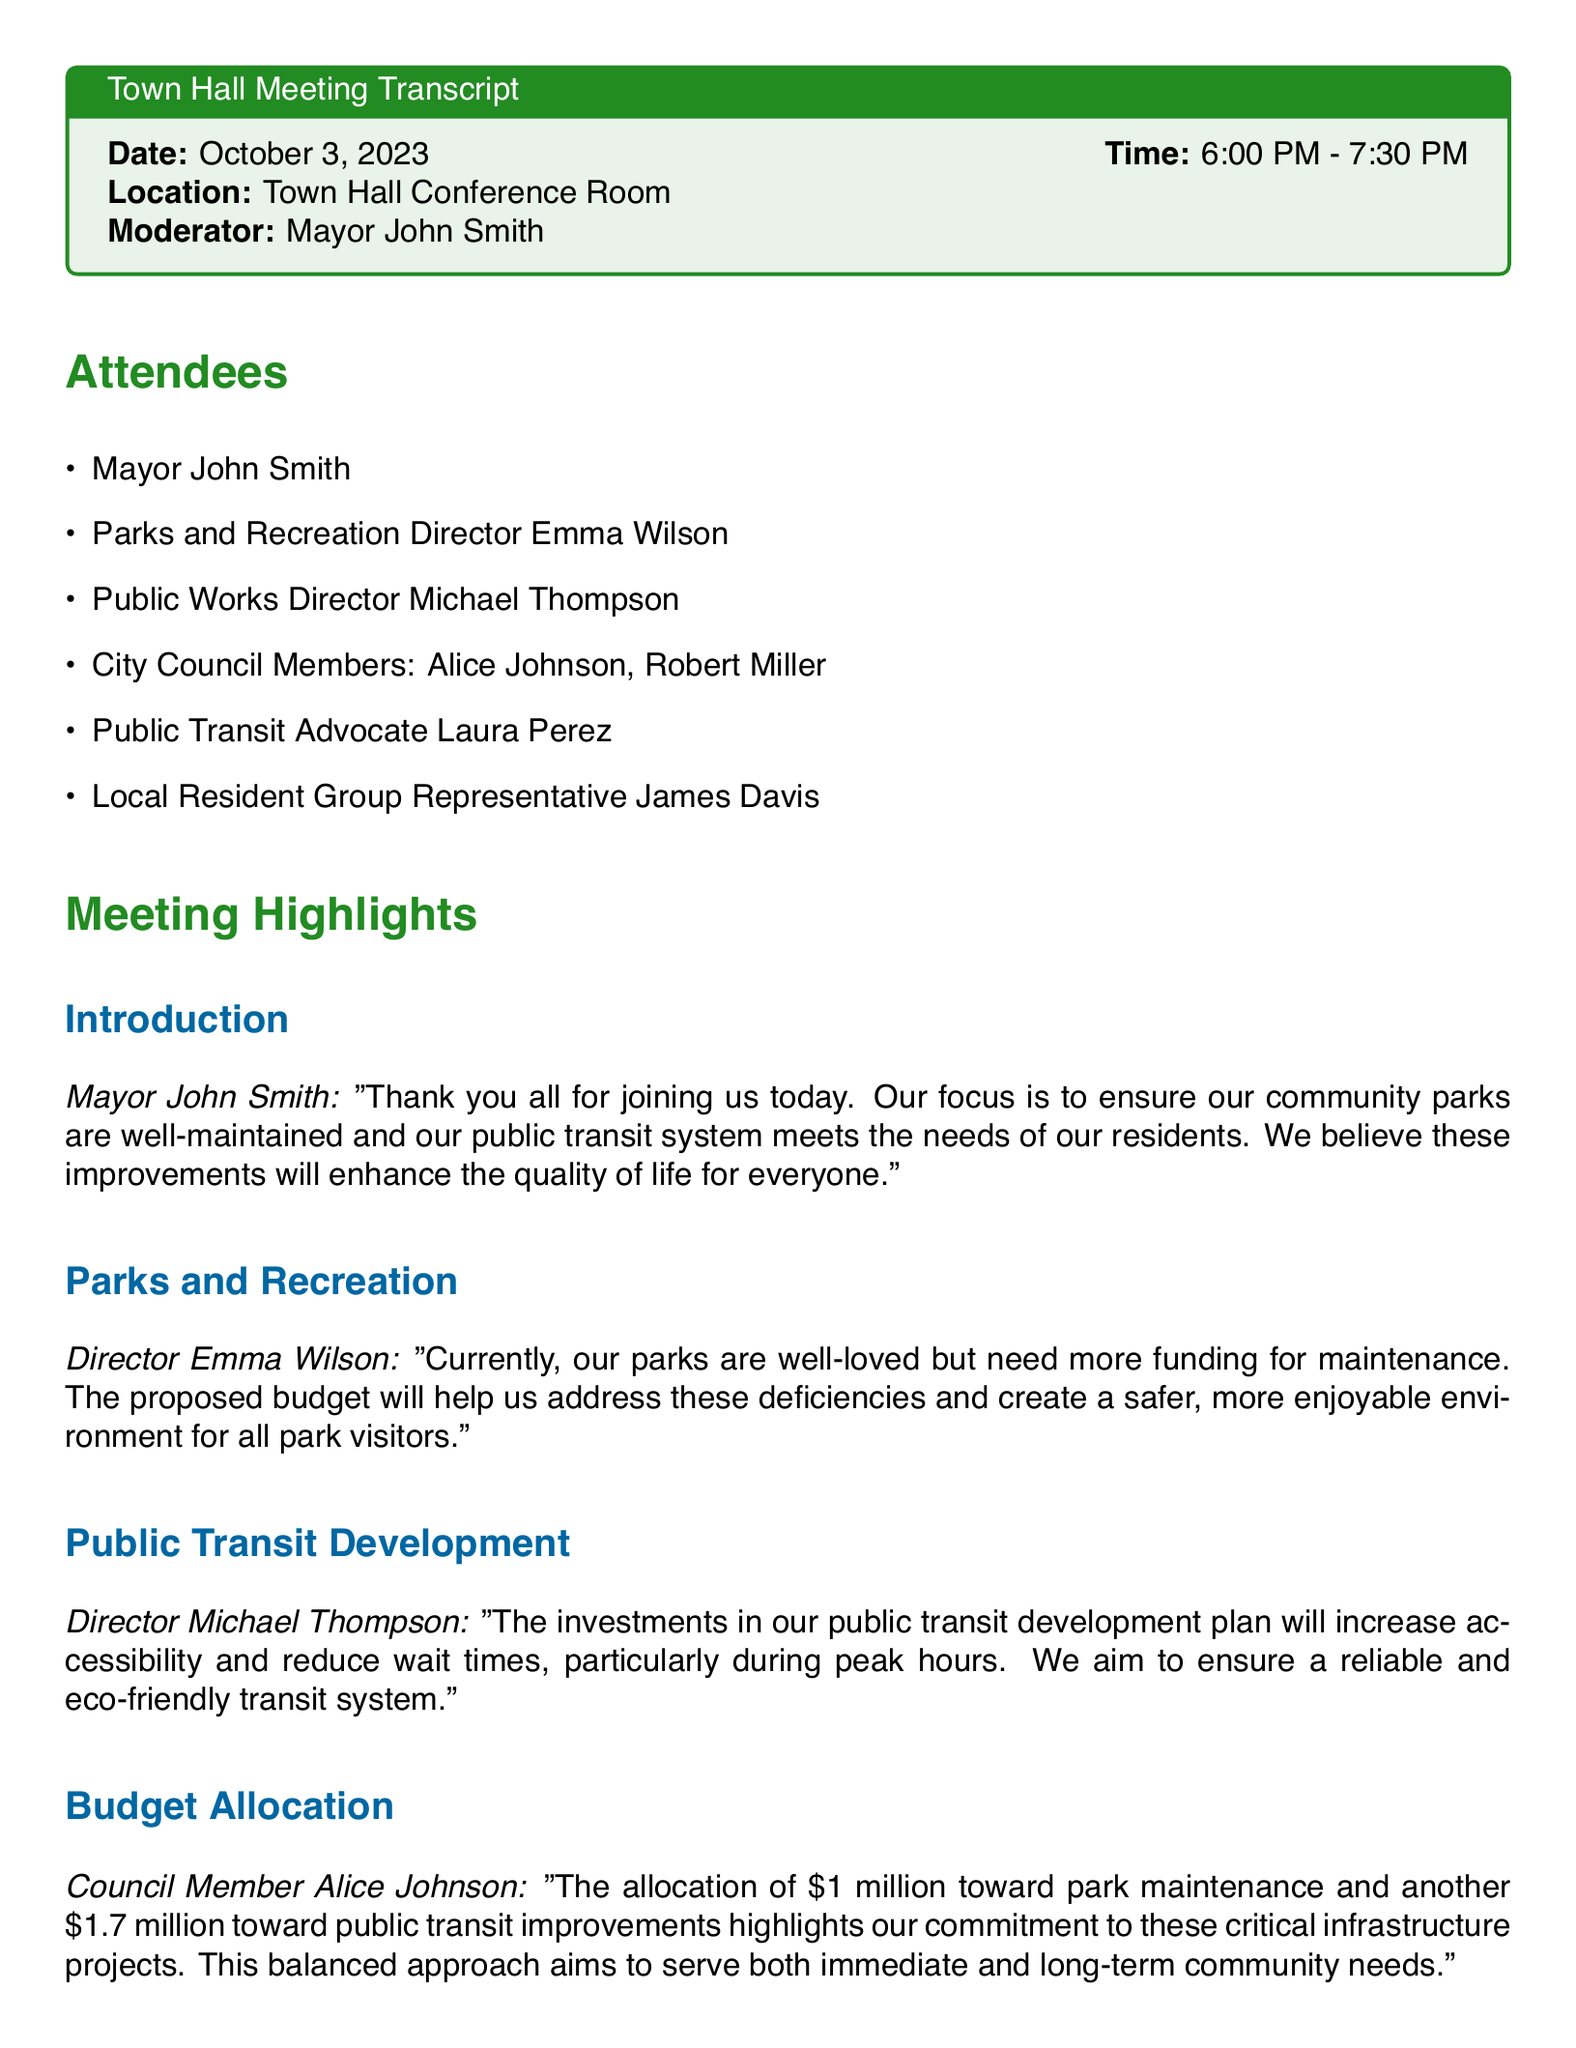What is the date of the meeting? The date of the meeting is clearly stated at the beginning of the document.
Answer: October 3, 2023 Who is the moderator of the meeting? The moderator is listed among the attendees at the start of the document.
Answer: Mayor John Smith How much funding is allocated for park maintenance? Budget allocation details are provided in the meeting highlights section.
Answer: $1 million What is the total budget allocated for public transit improvements? The total amount for public transit is specified in the budget allocation section.
Answer: $1.7 million What is the main goal of the public transit development plan? The main purpose is highlighted in Director Michael Thompson's statements about the plan.
Answer: Increase accessibility Which council member spoke about budget allocation? The document attributes a specific comment regarding budget allocation to one of the council members.
Answer: Alice Johnson What will the council do after reviewing feedback? The next steps indicate what actions will be taken following feedback.
Answer: Finalize the budget allocation What does Laura Perez advocate for regarding public transit? Laura Perez expresses her support for a particular focus related to public transit in the document.
Answer: Environmental goals How long did the meeting last? The meeting duration can be calculated from the start and end times indicated at the beginning.
Answer: 1 hour 30 minutes 